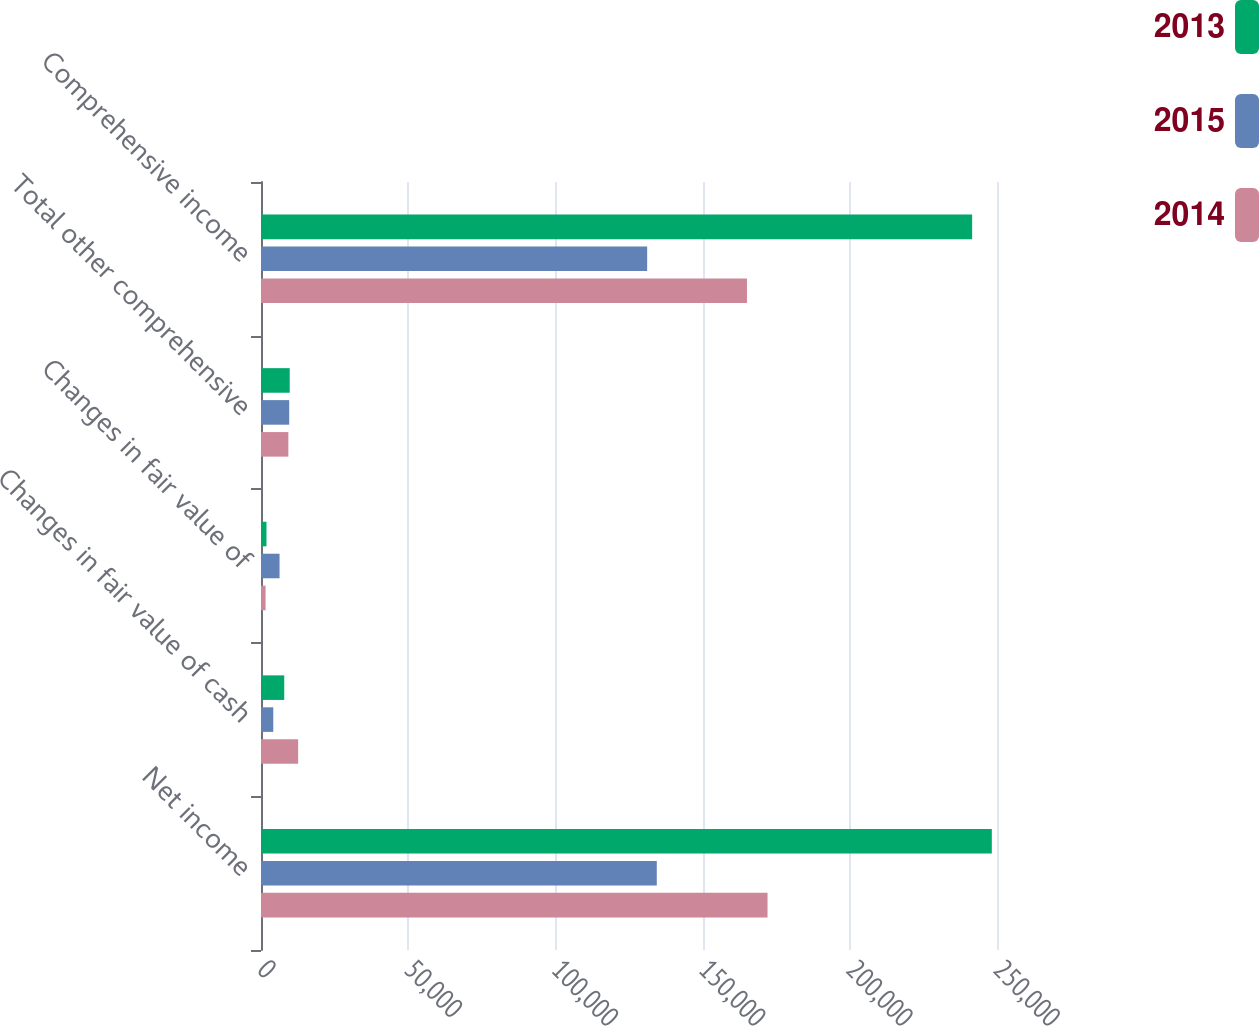<chart> <loc_0><loc_0><loc_500><loc_500><stacked_bar_chart><ecel><fcel>Net income<fcel>Changes in fair value of cash<fcel>Changes in fair value of<fcel>Total other comprehensive<fcel>Comprehensive income<nl><fcel>2013<fcel>248239<fcel>7893<fcel>1865<fcel>9758<fcel>241561<nl><fcel>2015<fcel>134438<fcel>4168<fcel>6302<fcel>9584<fcel>131170<nl><fcel>2014<fcel>172055<fcel>12614<fcel>1556<fcel>9291<fcel>165072<nl></chart> 